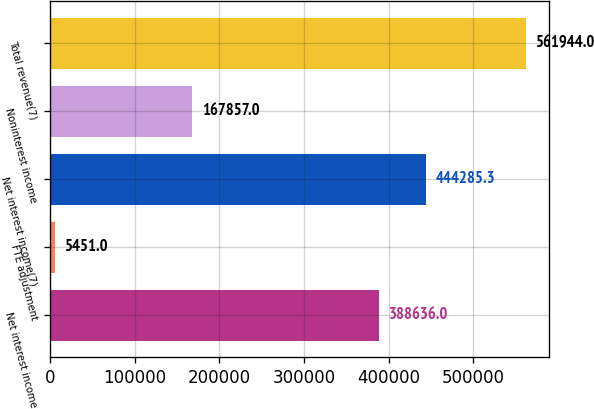Convert chart. <chart><loc_0><loc_0><loc_500><loc_500><bar_chart><fcel>Net interest income<fcel>FTE adjustment<fcel>Net interest income(7)<fcel>Noninterest income<fcel>Total revenue(7)<nl><fcel>388636<fcel>5451<fcel>444285<fcel>167857<fcel>561944<nl></chart> 